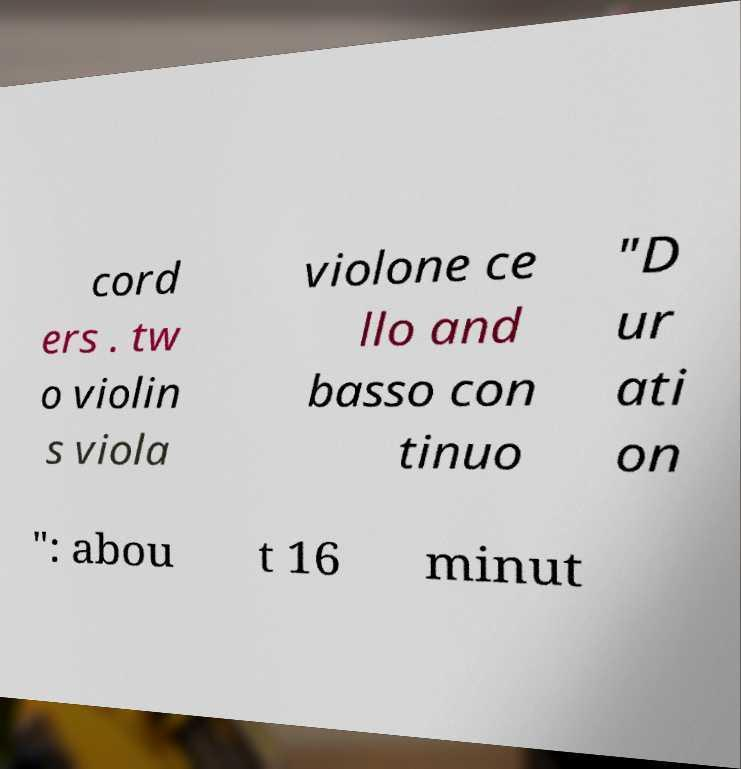Please read and relay the text visible in this image. What does it say? cord ers . tw o violin s viola violone ce llo and basso con tinuo "D ur ati on ": abou t 16 minut 